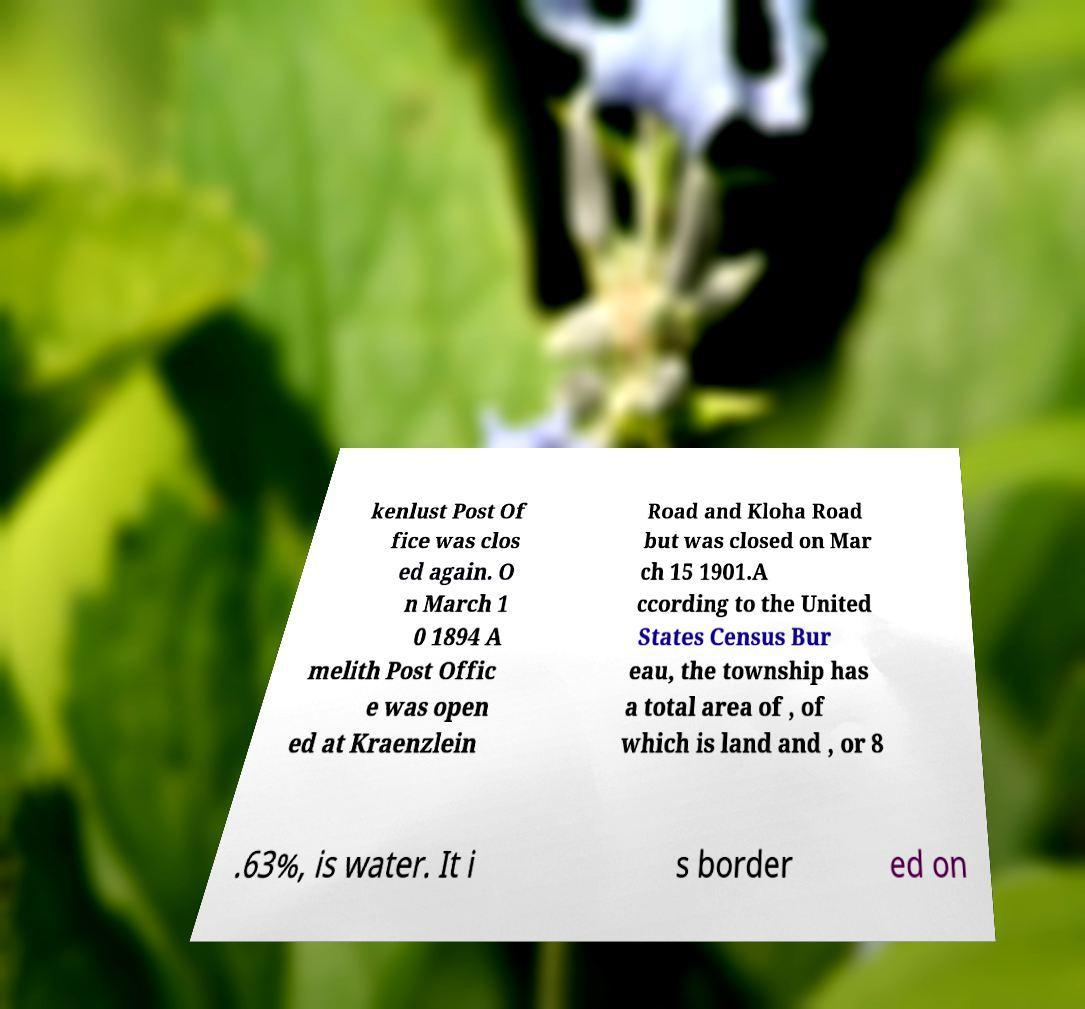Please read and relay the text visible in this image. What does it say? kenlust Post Of fice was clos ed again. O n March 1 0 1894 A melith Post Offic e was open ed at Kraenzlein Road and Kloha Road but was closed on Mar ch 15 1901.A ccording to the United States Census Bur eau, the township has a total area of , of which is land and , or 8 .63%, is water. It i s border ed on 